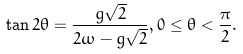<formula> <loc_0><loc_0><loc_500><loc_500>\tan 2 \theta = \frac { g \sqrt { 2 } } { 2 \omega - g \sqrt { 2 } } , 0 \leq \theta < \frac { \pi } { 2 } .</formula> 